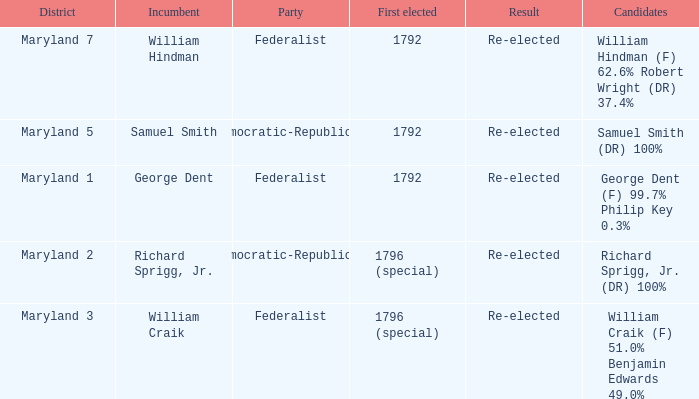What is the party when the incumbent is samuel smith? Democratic-Republican. 